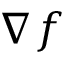<formula> <loc_0><loc_0><loc_500><loc_500>\nabla f</formula> 